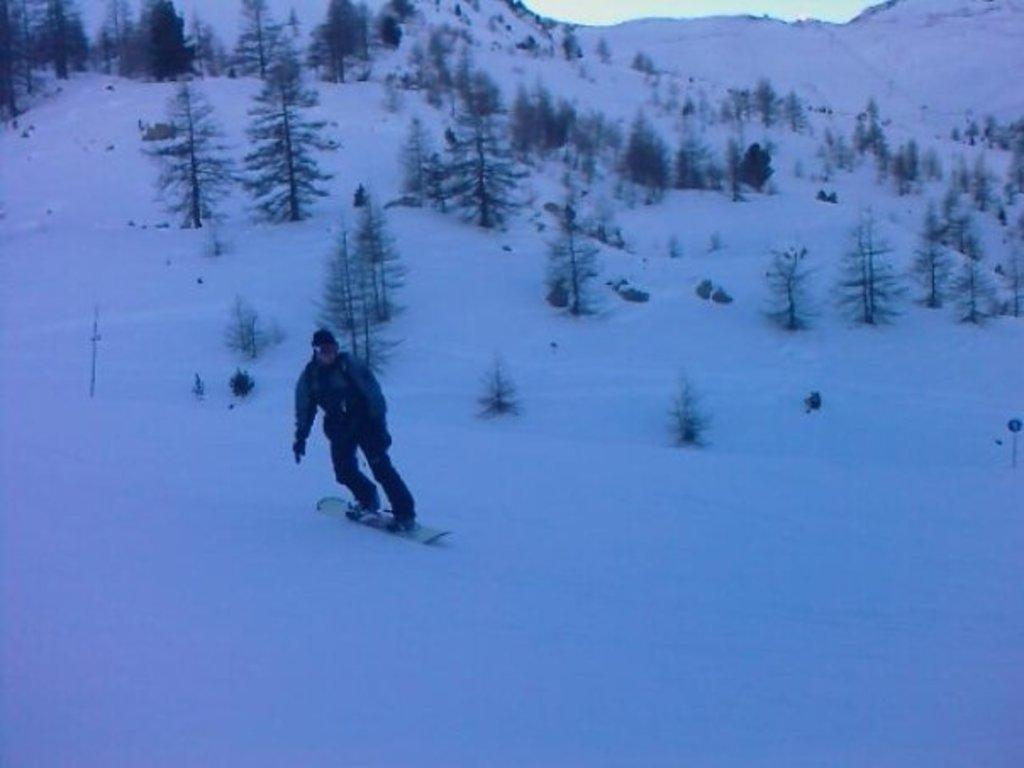What is the person in the image doing? The person is skating with a snowboard. What type of terrain is the person skating on? The skating is taking place on snow. What can be seen in the background of the image? There are trees, plants, snow, and mountains in the background of the image. What type of death can be seen in the image? There is no death present in the image; it features a person skating with a snowboard. How does the person shake the snow off their snowboard in the image? The person does not shake the snow off their snowboard in the image; they are actively skating on the snow. 